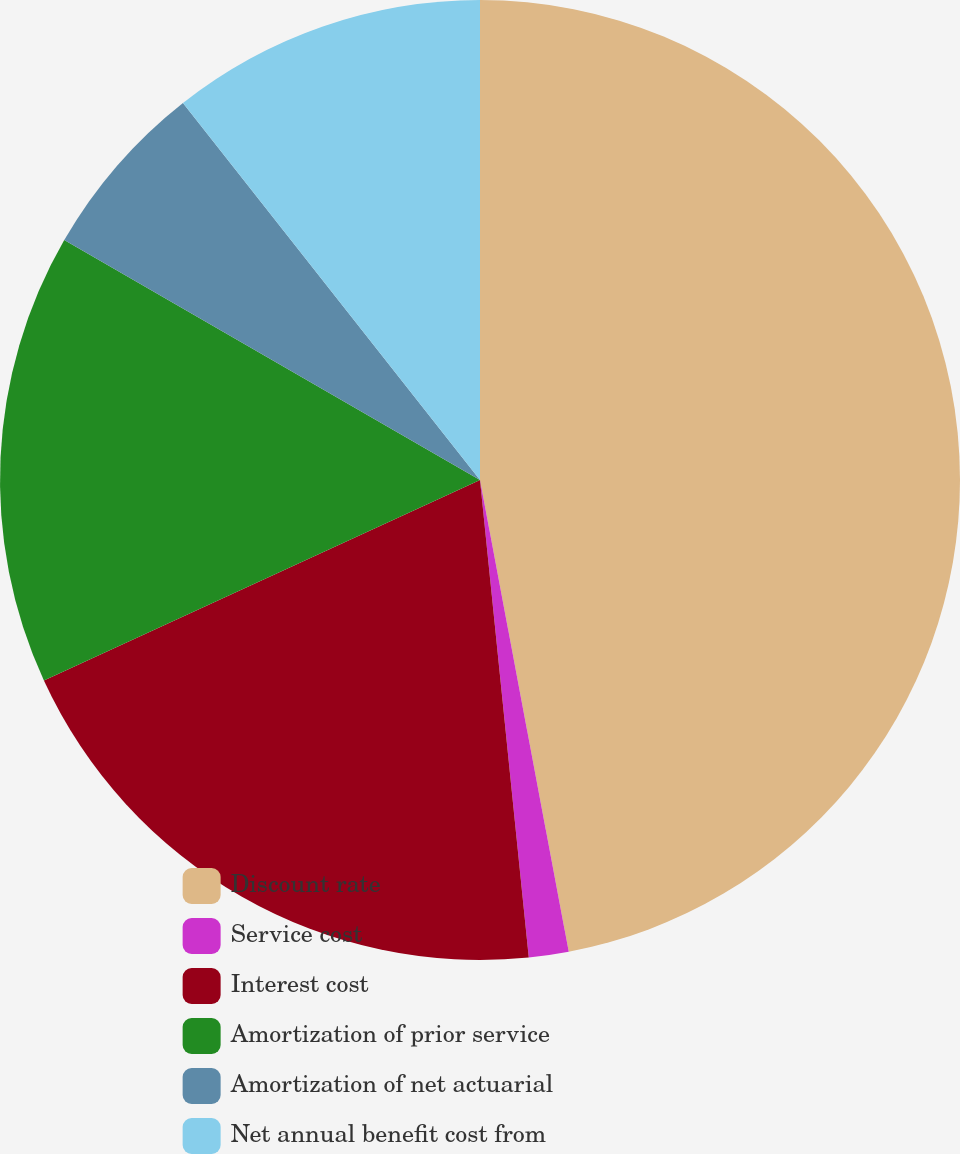<chart> <loc_0><loc_0><loc_500><loc_500><pie_chart><fcel>Discount rate<fcel>Service cost<fcel>Interest cost<fcel>Amortization of prior service<fcel>Amortization of net actuarial<fcel>Net annual benefit cost from<nl><fcel>47.04%<fcel>1.34%<fcel>19.76%<fcel>15.19%<fcel>6.05%<fcel>10.62%<nl></chart> 